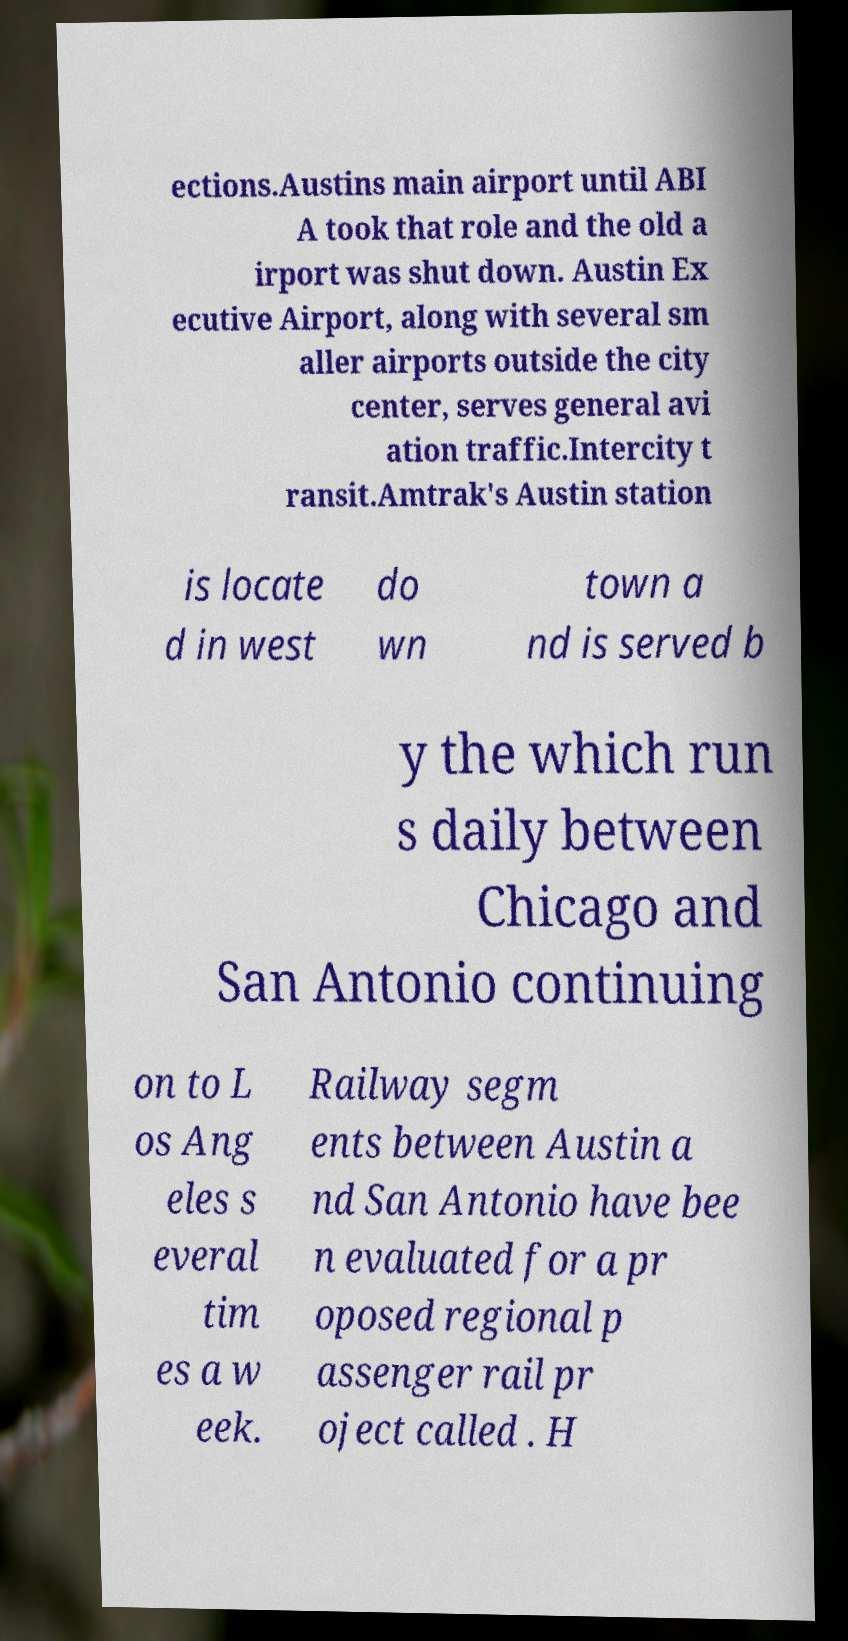For documentation purposes, I need the text within this image transcribed. Could you provide that? ections.Austins main airport until ABI A took that role and the old a irport was shut down. Austin Ex ecutive Airport, along with several sm aller airports outside the city center, serves general avi ation traffic.Intercity t ransit.Amtrak's Austin station is locate d in west do wn town a nd is served b y the which run s daily between Chicago and San Antonio continuing on to L os Ang eles s everal tim es a w eek. Railway segm ents between Austin a nd San Antonio have bee n evaluated for a pr oposed regional p assenger rail pr oject called . H 